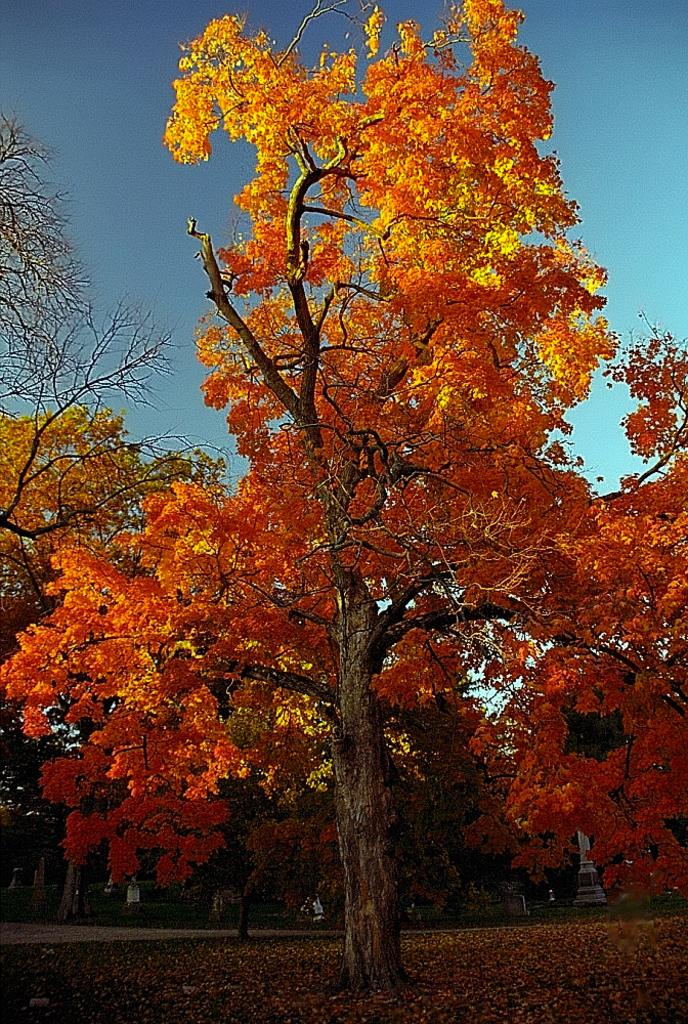What type of vegetation can be seen in the image? There are trees in the image. What part of the natural environment is visible in the background of the image? The sky is visible in the background of the image. What is present at the bottom of the image? There are leaves at the bottom of the image. What word is written on the mitten in the image? There is no mitten present in the image, so no word can be found on it. 